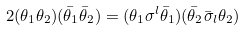Convert formula to latex. <formula><loc_0><loc_0><loc_500><loc_500>2 ( \theta _ { 1 } \theta _ { 2 } ) ( \bar { \theta } _ { 1 } \bar { \theta } _ { 2 } ) = ( \theta _ { 1 } \sigma ^ { l } \bar { \theta } _ { 1 } ) ( \bar { \theta } _ { 2 } \bar { \sigma } _ { l } \theta _ { 2 } )</formula> 